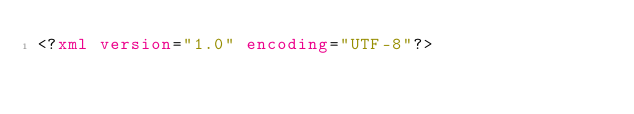Convert code to text. <code><loc_0><loc_0><loc_500><loc_500><_XML_><?xml version="1.0" encoding="UTF-8"?></code> 